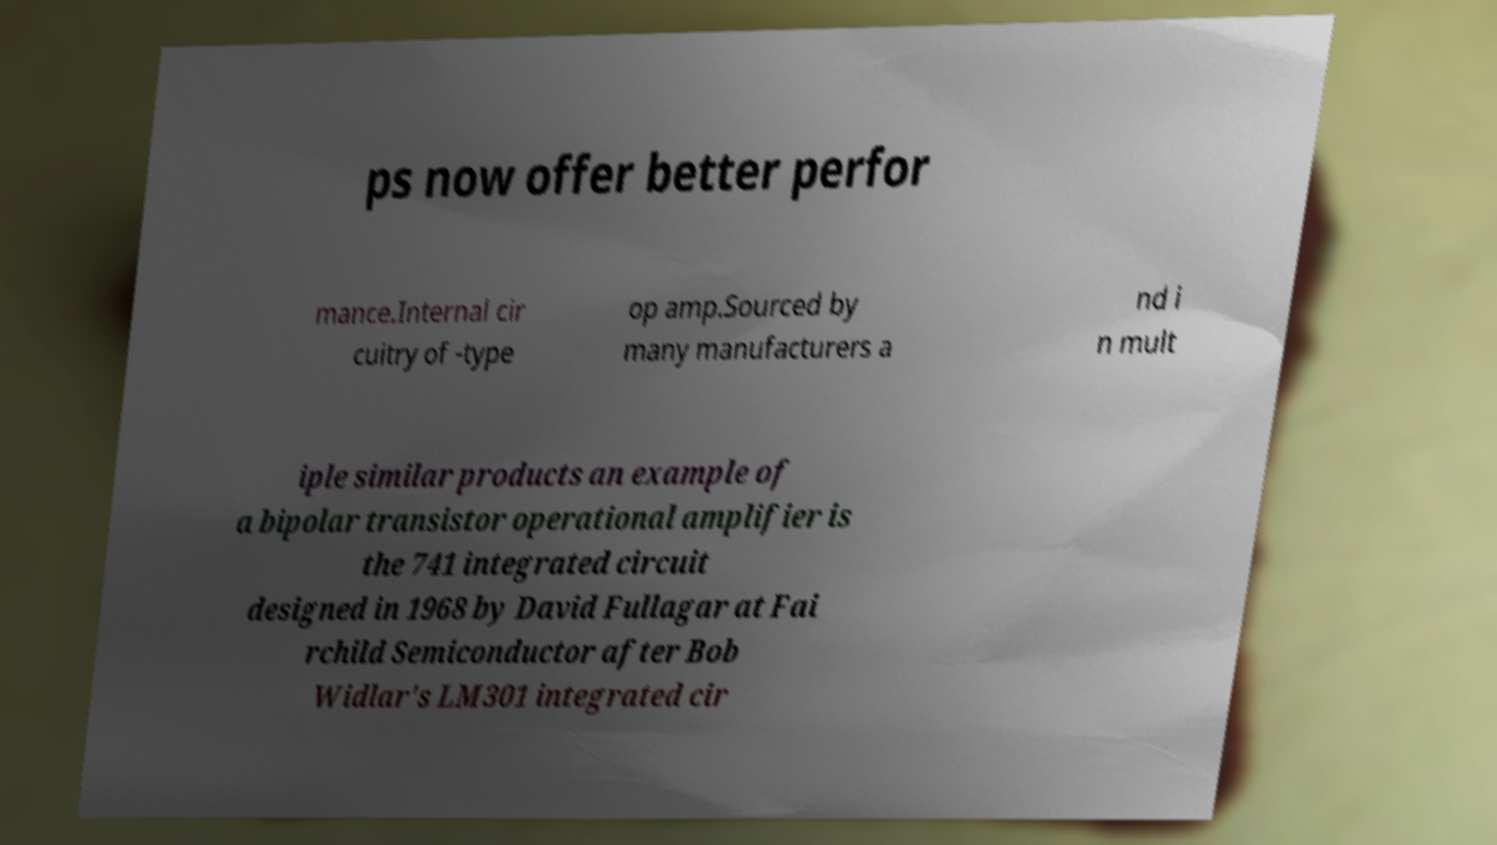Can you read and provide the text displayed in the image?This photo seems to have some interesting text. Can you extract and type it out for me? ps now offer better perfor mance.Internal cir cuitry of -type op amp.Sourced by many manufacturers a nd i n mult iple similar products an example of a bipolar transistor operational amplifier is the 741 integrated circuit designed in 1968 by David Fullagar at Fai rchild Semiconductor after Bob Widlar's LM301 integrated cir 